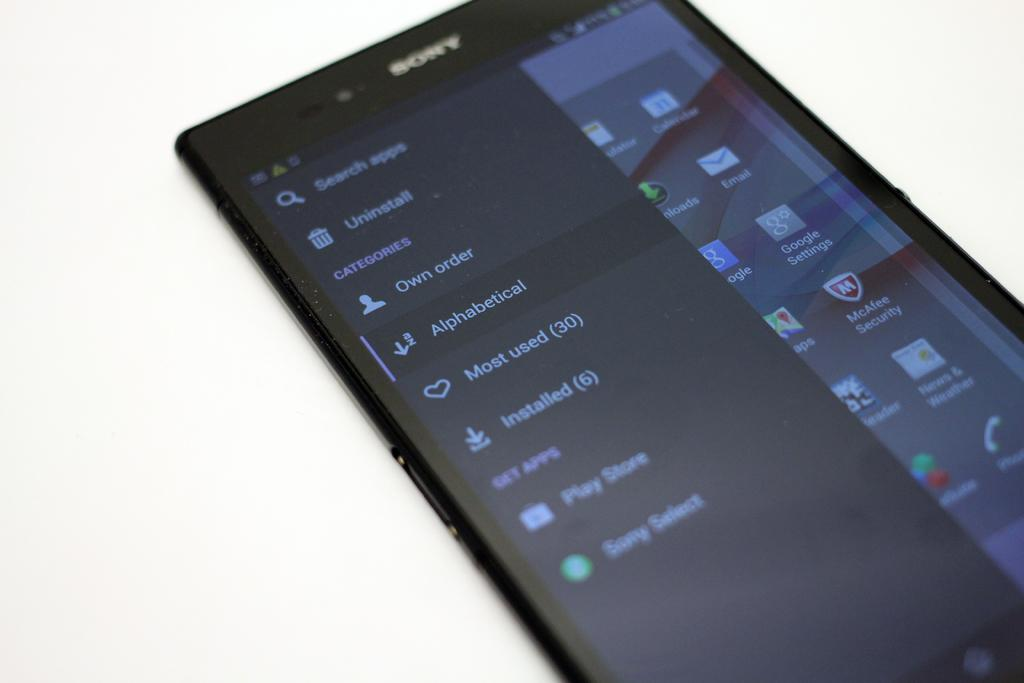<image>
Create a compact narrative representing the image presented. A Sony phone lays on its back with the search tab open on it. 